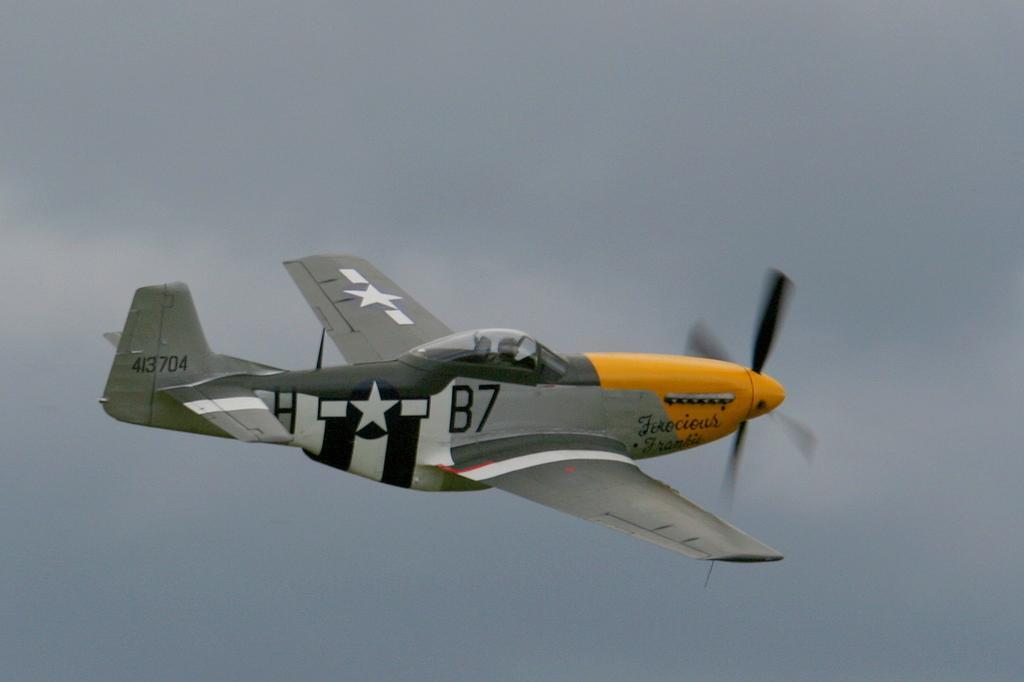Could you give a brief overview of what you see in this image? In the image a person is riding a plane. Behind the plane there is sky. 